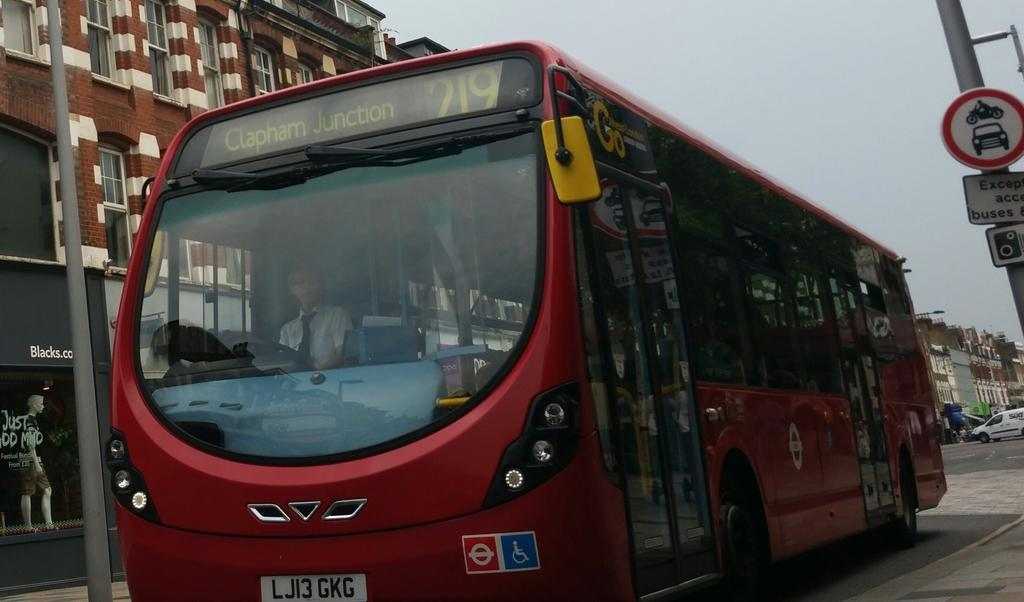What is the person in the image doing? There is a person sitting in a vehicle in the image. What can be seen in the background of the image? There are buildings in the image. What else is present in the image besides the person and the vehicle? There are poles, other vehicles, and boards with text in the image. Are there any fairies flying around the person in the image? No, there are no fairies present in the image. 